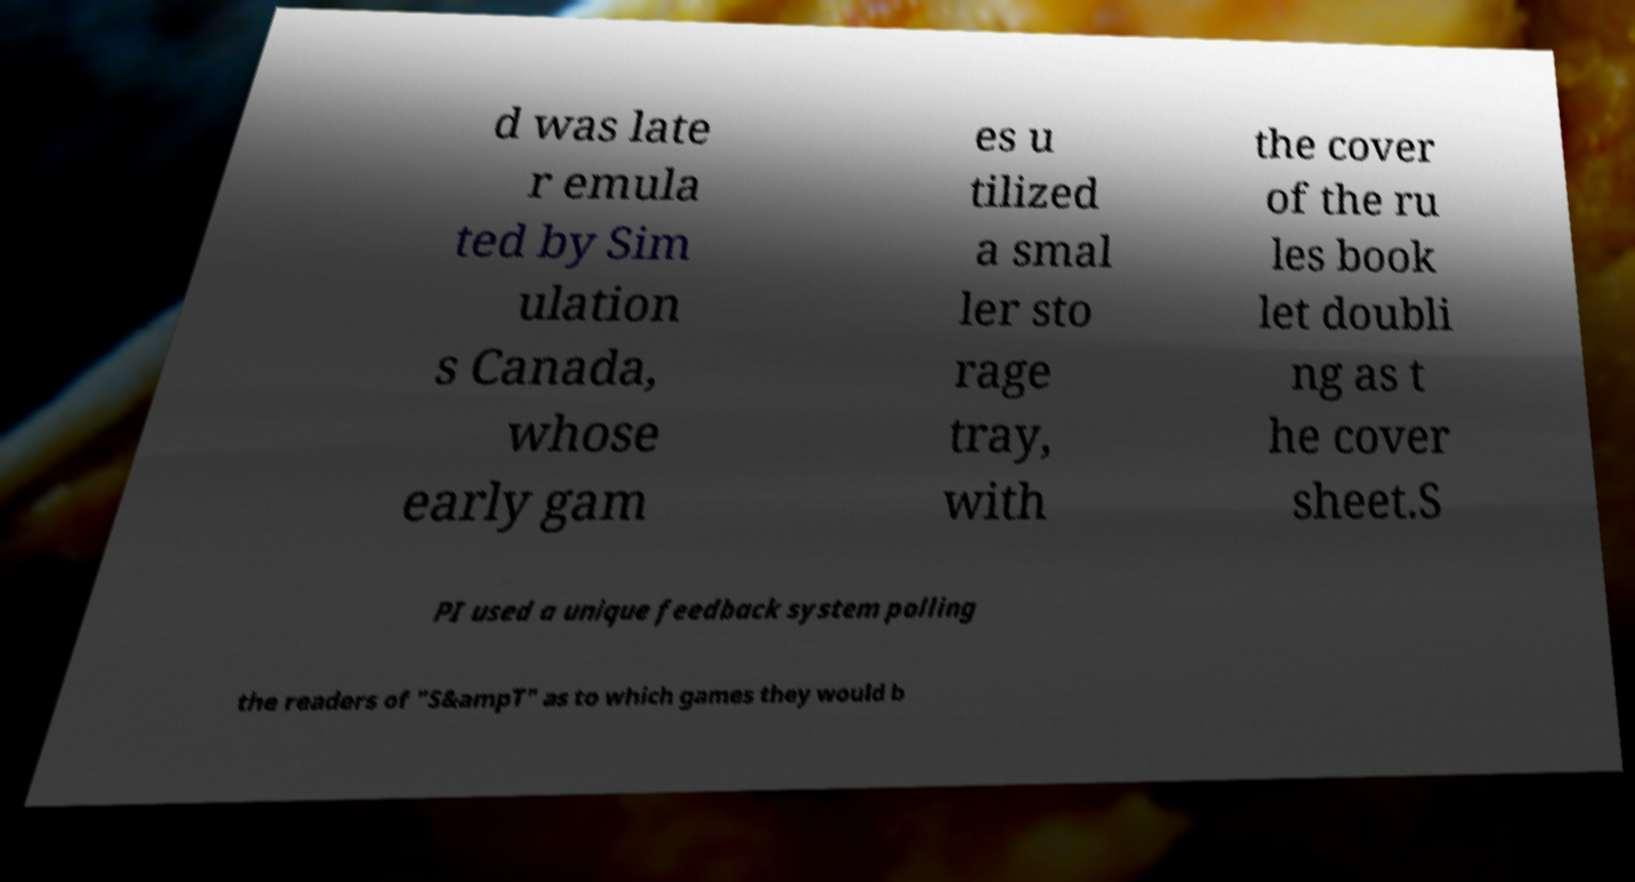There's text embedded in this image that I need extracted. Can you transcribe it verbatim? d was late r emula ted by Sim ulation s Canada, whose early gam es u tilized a smal ler sto rage tray, with the cover of the ru les book let doubli ng as t he cover sheet.S PI used a unique feedback system polling the readers of "S&ampT" as to which games they would b 